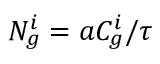<formula> <loc_0><loc_0><loc_500><loc_500>N _ { g } ^ { i } = a C _ { g } ^ { i } / \tau</formula> 